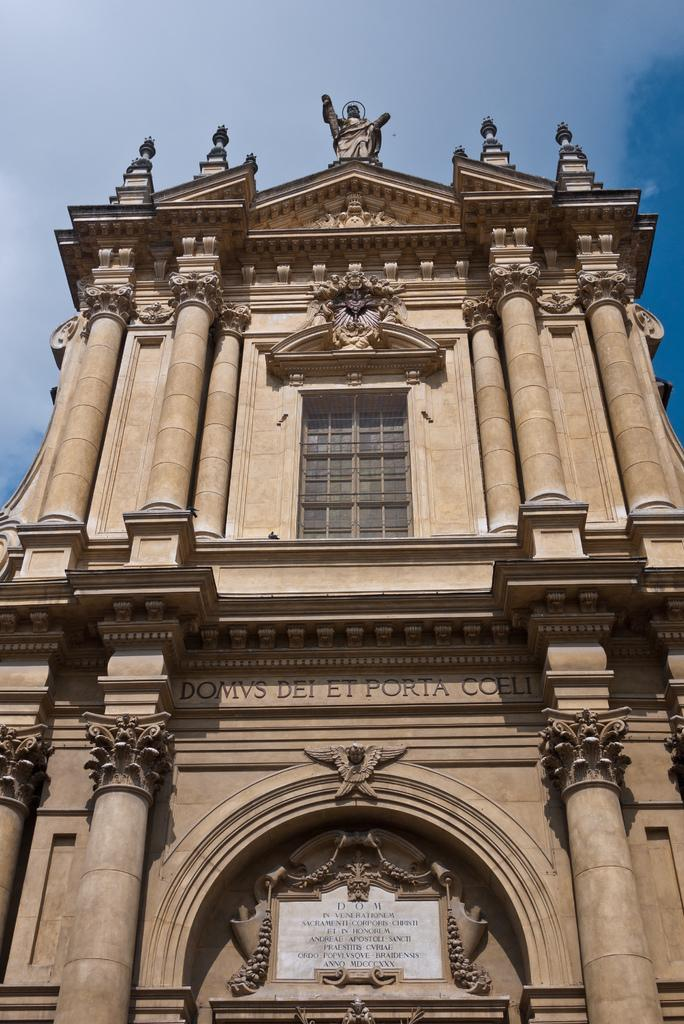What type of structure is present in the image? There is a building in the image. What decorative elements can be seen on the building's walls? The building has sculptures and designs on its walls. Can you see any flowers growing on the building in the image? There are no flowers visible on the building in the image. Is there a girl wearing a coat standing next to the building in the image? There is no girl wearing a coat present in the image. 